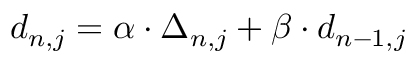Convert formula to latex. <formula><loc_0><loc_0><loc_500><loc_500>d _ { n , j } = \alpha \cdot \Delta _ { n , j } + \beta \cdot d _ { n - 1 , j }</formula> 